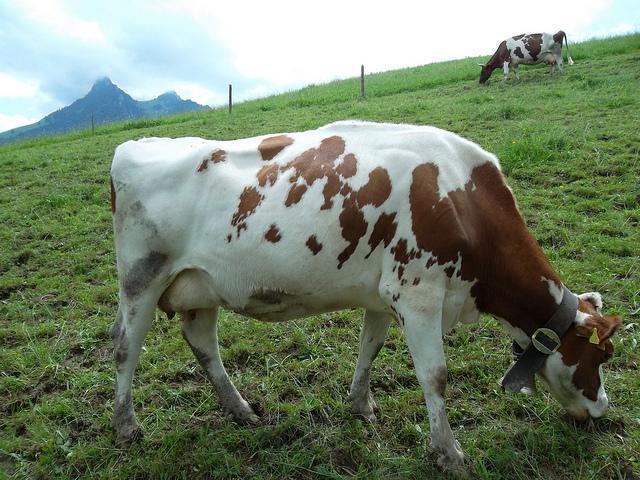How many cows are in the picture?
Give a very brief answer. 2. How many people are wearing glasses?
Give a very brief answer. 0. 